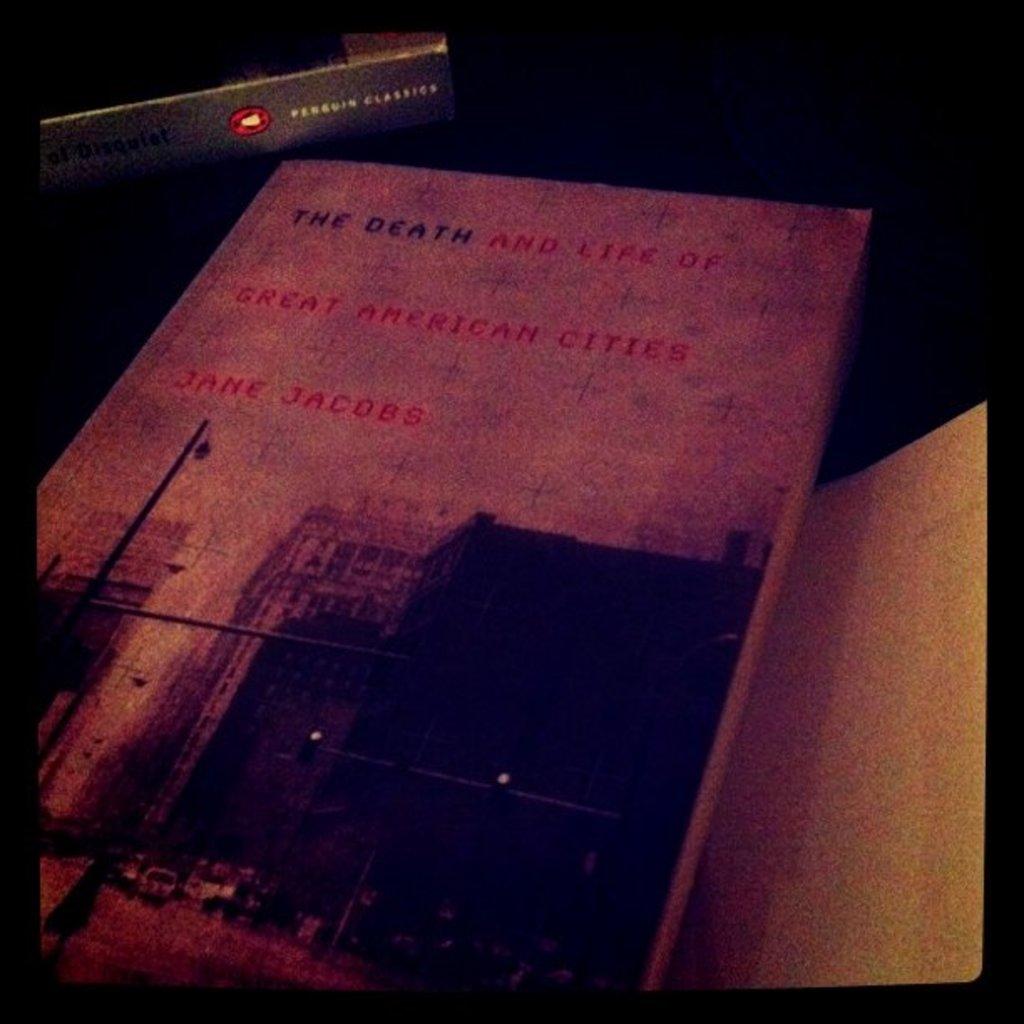What is the name of the book?
Offer a terse response. The death and life of great american cities. Who is the author?
Your answer should be very brief. Jane jacobs. 